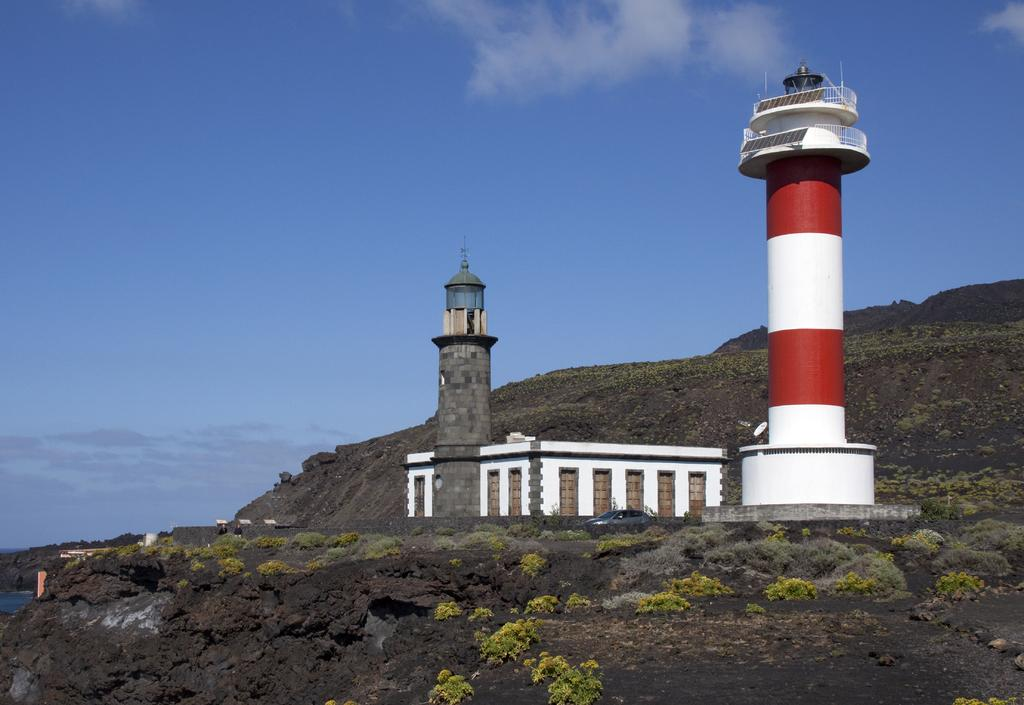What is the main structure in the image? There is a lighthouse in the image. What other buildings or structures can be seen in the image? There is a building in the image. What mode of transportation is present in the image? There is a car in the image. What type of natural feature is visible in the image? There is a hill in the image. What type of vegetation can be seen in the image? There are plants visible in the image. What is visible in the background of the image? The sky is visible in the background of the image, and there are clouds in the sky. How many jellyfish are swimming in the sea near the lighthouse in the image? There are no jellyfish visible in the image; it only shows a lighthouse, a building, a car, a hill, plants, the sky, and clouds. 